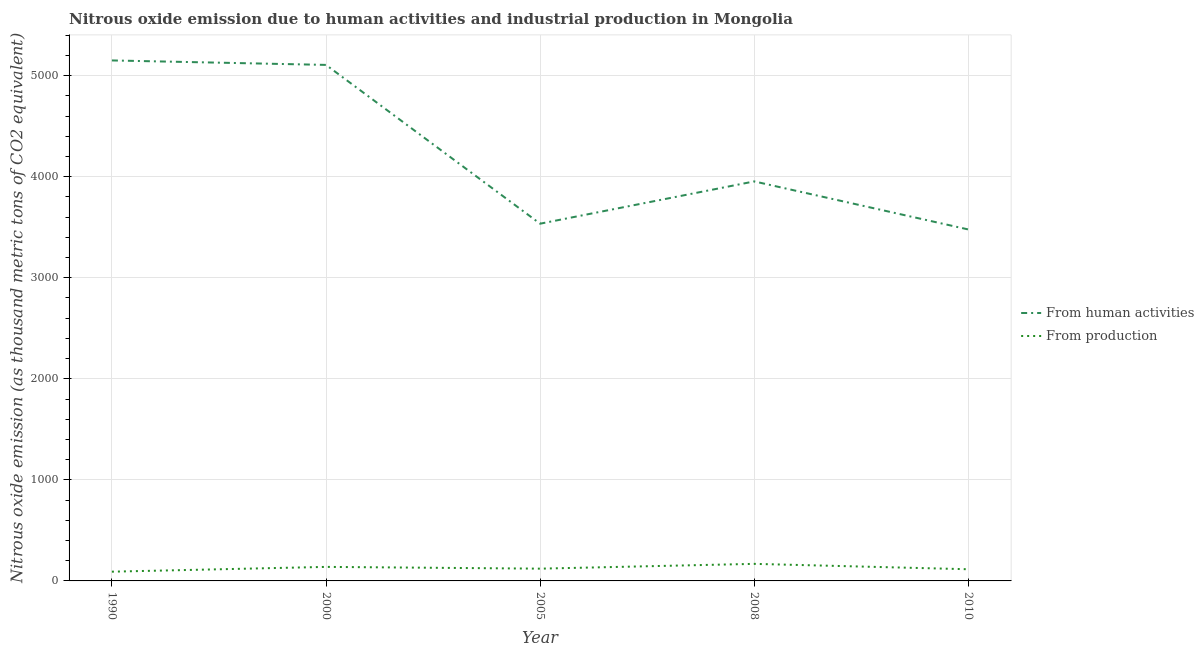How many different coloured lines are there?
Your response must be concise. 2. Does the line corresponding to amount of emissions generated from industries intersect with the line corresponding to amount of emissions from human activities?
Keep it short and to the point. No. Is the number of lines equal to the number of legend labels?
Your answer should be compact. Yes. What is the amount of emissions generated from industries in 2010?
Provide a succinct answer. 115.5. Across all years, what is the maximum amount of emissions from human activities?
Ensure brevity in your answer.  5151. Across all years, what is the minimum amount of emissions generated from industries?
Keep it short and to the point. 91.5. In which year was the amount of emissions from human activities maximum?
Keep it short and to the point. 1990. What is the total amount of emissions generated from industries in the graph?
Offer a very short reply. 636.2. What is the difference between the amount of emissions from human activities in 2000 and that in 2010?
Your answer should be very brief. 1628.6. What is the difference between the amount of emissions from human activities in 2008 and the amount of emissions generated from industries in 1990?
Keep it short and to the point. 3862.3. What is the average amount of emissions from human activities per year?
Offer a very short reply. 4245.04. In the year 2010, what is the difference between the amount of emissions from human activities and amount of emissions generated from industries?
Provide a short and direct response. 3362.7. What is the ratio of the amount of emissions from human activities in 1990 to that in 2000?
Make the answer very short. 1.01. Is the amount of emissions generated from industries in 1990 less than that in 2008?
Make the answer very short. Yes. What is the difference between the highest and the second highest amount of emissions generated from industries?
Your answer should be very brief. 30. What is the difference between the highest and the lowest amount of emissions from human activities?
Offer a terse response. 1672.8. In how many years, is the amount of emissions generated from industries greater than the average amount of emissions generated from industries taken over all years?
Your response must be concise. 2. Does the amount of emissions generated from industries monotonically increase over the years?
Provide a succinct answer. No. Is the amount of emissions generated from industries strictly less than the amount of emissions from human activities over the years?
Keep it short and to the point. Yes. How many lines are there?
Offer a very short reply. 2. Are the values on the major ticks of Y-axis written in scientific E-notation?
Offer a terse response. No. Does the graph contain grids?
Provide a succinct answer. Yes. How many legend labels are there?
Give a very brief answer. 2. How are the legend labels stacked?
Keep it short and to the point. Vertical. What is the title of the graph?
Make the answer very short. Nitrous oxide emission due to human activities and industrial production in Mongolia. What is the label or title of the X-axis?
Offer a very short reply. Year. What is the label or title of the Y-axis?
Give a very brief answer. Nitrous oxide emission (as thousand metric tons of CO2 equivalent). What is the Nitrous oxide emission (as thousand metric tons of CO2 equivalent) in From human activities in 1990?
Keep it short and to the point. 5151. What is the Nitrous oxide emission (as thousand metric tons of CO2 equivalent) of From production in 1990?
Provide a succinct answer. 91.5. What is the Nitrous oxide emission (as thousand metric tons of CO2 equivalent) in From human activities in 2000?
Give a very brief answer. 5106.8. What is the Nitrous oxide emission (as thousand metric tons of CO2 equivalent) of From production in 2000?
Your answer should be compact. 138.9. What is the Nitrous oxide emission (as thousand metric tons of CO2 equivalent) in From human activities in 2005?
Your response must be concise. 3535.4. What is the Nitrous oxide emission (as thousand metric tons of CO2 equivalent) in From production in 2005?
Your answer should be compact. 121.4. What is the Nitrous oxide emission (as thousand metric tons of CO2 equivalent) of From human activities in 2008?
Ensure brevity in your answer.  3953.8. What is the Nitrous oxide emission (as thousand metric tons of CO2 equivalent) of From production in 2008?
Ensure brevity in your answer.  168.9. What is the Nitrous oxide emission (as thousand metric tons of CO2 equivalent) of From human activities in 2010?
Keep it short and to the point. 3478.2. What is the Nitrous oxide emission (as thousand metric tons of CO2 equivalent) in From production in 2010?
Your answer should be compact. 115.5. Across all years, what is the maximum Nitrous oxide emission (as thousand metric tons of CO2 equivalent) of From human activities?
Keep it short and to the point. 5151. Across all years, what is the maximum Nitrous oxide emission (as thousand metric tons of CO2 equivalent) in From production?
Offer a very short reply. 168.9. Across all years, what is the minimum Nitrous oxide emission (as thousand metric tons of CO2 equivalent) in From human activities?
Offer a terse response. 3478.2. Across all years, what is the minimum Nitrous oxide emission (as thousand metric tons of CO2 equivalent) in From production?
Ensure brevity in your answer.  91.5. What is the total Nitrous oxide emission (as thousand metric tons of CO2 equivalent) of From human activities in the graph?
Give a very brief answer. 2.12e+04. What is the total Nitrous oxide emission (as thousand metric tons of CO2 equivalent) of From production in the graph?
Provide a short and direct response. 636.2. What is the difference between the Nitrous oxide emission (as thousand metric tons of CO2 equivalent) of From human activities in 1990 and that in 2000?
Keep it short and to the point. 44.2. What is the difference between the Nitrous oxide emission (as thousand metric tons of CO2 equivalent) of From production in 1990 and that in 2000?
Keep it short and to the point. -47.4. What is the difference between the Nitrous oxide emission (as thousand metric tons of CO2 equivalent) of From human activities in 1990 and that in 2005?
Your answer should be very brief. 1615.6. What is the difference between the Nitrous oxide emission (as thousand metric tons of CO2 equivalent) of From production in 1990 and that in 2005?
Keep it short and to the point. -29.9. What is the difference between the Nitrous oxide emission (as thousand metric tons of CO2 equivalent) of From human activities in 1990 and that in 2008?
Offer a terse response. 1197.2. What is the difference between the Nitrous oxide emission (as thousand metric tons of CO2 equivalent) in From production in 1990 and that in 2008?
Make the answer very short. -77.4. What is the difference between the Nitrous oxide emission (as thousand metric tons of CO2 equivalent) of From human activities in 1990 and that in 2010?
Make the answer very short. 1672.8. What is the difference between the Nitrous oxide emission (as thousand metric tons of CO2 equivalent) in From production in 1990 and that in 2010?
Ensure brevity in your answer.  -24. What is the difference between the Nitrous oxide emission (as thousand metric tons of CO2 equivalent) of From human activities in 2000 and that in 2005?
Make the answer very short. 1571.4. What is the difference between the Nitrous oxide emission (as thousand metric tons of CO2 equivalent) of From human activities in 2000 and that in 2008?
Your response must be concise. 1153. What is the difference between the Nitrous oxide emission (as thousand metric tons of CO2 equivalent) in From production in 2000 and that in 2008?
Give a very brief answer. -30. What is the difference between the Nitrous oxide emission (as thousand metric tons of CO2 equivalent) in From human activities in 2000 and that in 2010?
Your response must be concise. 1628.6. What is the difference between the Nitrous oxide emission (as thousand metric tons of CO2 equivalent) of From production in 2000 and that in 2010?
Ensure brevity in your answer.  23.4. What is the difference between the Nitrous oxide emission (as thousand metric tons of CO2 equivalent) of From human activities in 2005 and that in 2008?
Provide a short and direct response. -418.4. What is the difference between the Nitrous oxide emission (as thousand metric tons of CO2 equivalent) in From production in 2005 and that in 2008?
Ensure brevity in your answer.  -47.5. What is the difference between the Nitrous oxide emission (as thousand metric tons of CO2 equivalent) in From human activities in 2005 and that in 2010?
Your answer should be very brief. 57.2. What is the difference between the Nitrous oxide emission (as thousand metric tons of CO2 equivalent) of From human activities in 2008 and that in 2010?
Provide a short and direct response. 475.6. What is the difference between the Nitrous oxide emission (as thousand metric tons of CO2 equivalent) in From production in 2008 and that in 2010?
Make the answer very short. 53.4. What is the difference between the Nitrous oxide emission (as thousand metric tons of CO2 equivalent) in From human activities in 1990 and the Nitrous oxide emission (as thousand metric tons of CO2 equivalent) in From production in 2000?
Offer a terse response. 5012.1. What is the difference between the Nitrous oxide emission (as thousand metric tons of CO2 equivalent) of From human activities in 1990 and the Nitrous oxide emission (as thousand metric tons of CO2 equivalent) of From production in 2005?
Keep it short and to the point. 5029.6. What is the difference between the Nitrous oxide emission (as thousand metric tons of CO2 equivalent) of From human activities in 1990 and the Nitrous oxide emission (as thousand metric tons of CO2 equivalent) of From production in 2008?
Your response must be concise. 4982.1. What is the difference between the Nitrous oxide emission (as thousand metric tons of CO2 equivalent) of From human activities in 1990 and the Nitrous oxide emission (as thousand metric tons of CO2 equivalent) of From production in 2010?
Offer a terse response. 5035.5. What is the difference between the Nitrous oxide emission (as thousand metric tons of CO2 equivalent) in From human activities in 2000 and the Nitrous oxide emission (as thousand metric tons of CO2 equivalent) in From production in 2005?
Your answer should be compact. 4985.4. What is the difference between the Nitrous oxide emission (as thousand metric tons of CO2 equivalent) in From human activities in 2000 and the Nitrous oxide emission (as thousand metric tons of CO2 equivalent) in From production in 2008?
Your response must be concise. 4937.9. What is the difference between the Nitrous oxide emission (as thousand metric tons of CO2 equivalent) in From human activities in 2000 and the Nitrous oxide emission (as thousand metric tons of CO2 equivalent) in From production in 2010?
Your answer should be very brief. 4991.3. What is the difference between the Nitrous oxide emission (as thousand metric tons of CO2 equivalent) in From human activities in 2005 and the Nitrous oxide emission (as thousand metric tons of CO2 equivalent) in From production in 2008?
Offer a very short reply. 3366.5. What is the difference between the Nitrous oxide emission (as thousand metric tons of CO2 equivalent) in From human activities in 2005 and the Nitrous oxide emission (as thousand metric tons of CO2 equivalent) in From production in 2010?
Make the answer very short. 3419.9. What is the difference between the Nitrous oxide emission (as thousand metric tons of CO2 equivalent) in From human activities in 2008 and the Nitrous oxide emission (as thousand metric tons of CO2 equivalent) in From production in 2010?
Provide a short and direct response. 3838.3. What is the average Nitrous oxide emission (as thousand metric tons of CO2 equivalent) of From human activities per year?
Offer a very short reply. 4245.04. What is the average Nitrous oxide emission (as thousand metric tons of CO2 equivalent) in From production per year?
Your answer should be very brief. 127.24. In the year 1990, what is the difference between the Nitrous oxide emission (as thousand metric tons of CO2 equivalent) of From human activities and Nitrous oxide emission (as thousand metric tons of CO2 equivalent) of From production?
Offer a very short reply. 5059.5. In the year 2000, what is the difference between the Nitrous oxide emission (as thousand metric tons of CO2 equivalent) in From human activities and Nitrous oxide emission (as thousand metric tons of CO2 equivalent) in From production?
Provide a short and direct response. 4967.9. In the year 2005, what is the difference between the Nitrous oxide emission (as thousand metric tons of CO2 equivalent) in From human activities and Nitrous oxide emission (as thousand metric tons of CO2 equivalent) in From production?
Keep it short and to the point. 3414. In the year 2008, what is the difference between the Nitrous oxide emission (as thousand metric tons of CO2 equivalent) of From human activities and Nitrous oxide emission (as thousand metric tons of CO2 equivalent) of From production?
Provide a succinct answer. 3784.9. In the year 2010, what is the difference between the Nitrous oxide emission (as thousand metric tons of CO2 equivalent) in From human activities and Nitrous oxide emission (as thousand metric tons of CO2 equivalent) in From production?
Provide a short and direct response. 3362.7. What is the ratio of the Nitrous oxide emission (as thousand metric tons of CO2 equivalent) of From human activities in 1990 to that in 2000?
Your answer should be compact. 1.01. What is the ratio of the Nitrous oxide emission (as thousand metric tons of CO2 equivalent) in From production in 1990 to that in 2000?
Ensure brevity in your answer.  0.66. What is the ratio of the Nitrous oxide emission (as thousand metric tons of CO2 equivalent) of From human activities in 1990 to that in 2005?
Offer a very short reply. 1.46. What is the ratio of the Nitrous oxide emission (as thousand metric tons of CO2 equivalent) of From production in 1990 to that in 2005?
Your response must be concise. 0.75. What is the ratio of the Nitrous oxide emission (as thousand metric tons of CO2 equivalent) of From human activities in 1990 to that in 2008?
Keep it short and to the point. 1.3. What is the ratio of the Nitrous oxide emission (as thousand metric tons of CO2 equivalent) in From production in 1990 to that in 2008?
Provide a succinct answer. 0.54. What is the ratio of the Nitrous oxide emission (as thousand metric tons of CO2 equivalent) in From human activities in 1990 to that in 2010?
Make the answer very short. 1.48. What is the ratio of the Nitrous oxide emission (as thousand metric tons of CO2 equivalent) in From production in 1990 to that in 2010?
Your response must be concise. 0.79. What is the ratio of the Nitrous oxide emission (as thousand metric tons of CO2 equivalent) of From human activities in 2000 to that in 2005?
Your answer should be compact. 1.44. What is the ratio of the Nitrous oxide emission (as thousand metric tons of CO2 equivalent) of From production in 2000 to that in 2005?
Provide a short and direct response. 1.14. What is the ratio of the Nitrous oxide emission (as thousand metric tons of CO2 equivalent) in From human activities in 2000 to that in 2008?
Your answer should be very brief. 1.29. What is the ratio of the Nitrous oxide emission (as thousand metric tons of CO2 equivalent) of From production in 2000 to that in 2008?
Your answer should be very brief. 0.82. What is the ratio of the Nitrous oxide emission (as thousand metric tons of CO2 equivalent) of From human activities in 2000 to that in 2010?
Provide a short and direct response. 1.47. What is the ratio of the Nitrous oxide emission (as thousand metric tons of CO2 equivalent) of From production in 2000 to that in 2010?
Provide a succinct answer. 1.2. What is the ratio of the Nitrous oxide emission (as thousand metric tons of CO2 equivalent) of From human activities in 2005 to that in 2008?
Give a very brief answer. 0.89. What is the ratio of the Nitrous oxide emission (as thousand metric tons of CO2 equivalent) in From production in 2005 to that in 2008?
Your response must be concise. 0.72. What is the ratio of the Nitrous oxide emission (as thousand metric tons of CO2 equivalent) in From human activities in 2005 to that in 2010?
Offer a terse response. 1.02. What is the ratio of the Nitrous oxide emission (as thousand metric tons of CO2 equivalent) of From production in 2005 to that in 2010?
Your answer should be very brief. 1.05. What is the ratio of the Nitrous oxide emission (as thousand metric tons of CO2 equivalent) in From human activities in 2008 to that in 2010?
Ensure brevity in your answer.  1.14. What is the ratio of the Nitrous oxide emission (as thousand metric tons of CO2 equivalent) in From production in 2008 to that in 2010?
Give a very brief answer. 1.46. What is the difference between the highest and the second highest Nitrous oxide emission (as thousand metric tons of CO2 equivalent) of From human activities?
Offer a terse response. 44.2. What is the difference between the highest and the lowest Nitrous oxide emission (as thousand metric tons of CO2 equivalent) of From human activities?
Your answer should be very brief. 1672.8. What is the difference between the highest and the lowest Nitrous oxide emission (as thousand metric tons of CO2 equivalent) of From production?
Offer a terse response. 77.4. 